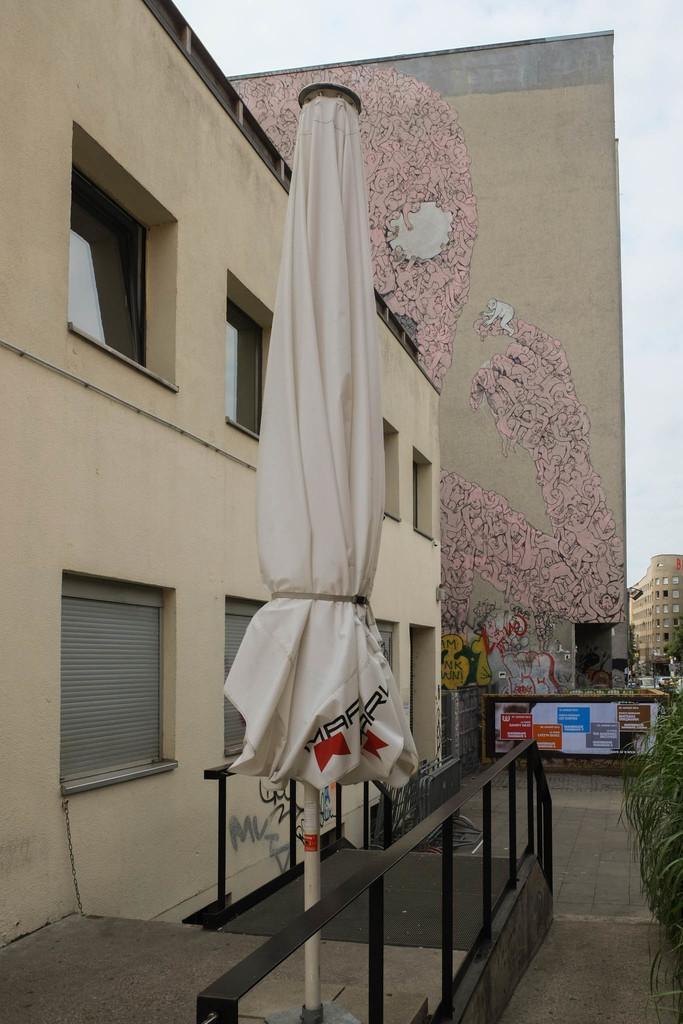How would you summarize this image in a sentence or two? This image consists of a building along with windows. In the background, there is a big wall on which there is a panting. In the middle, there is an umbrella. At the bottom, there is ground. To the right, there are plants. 